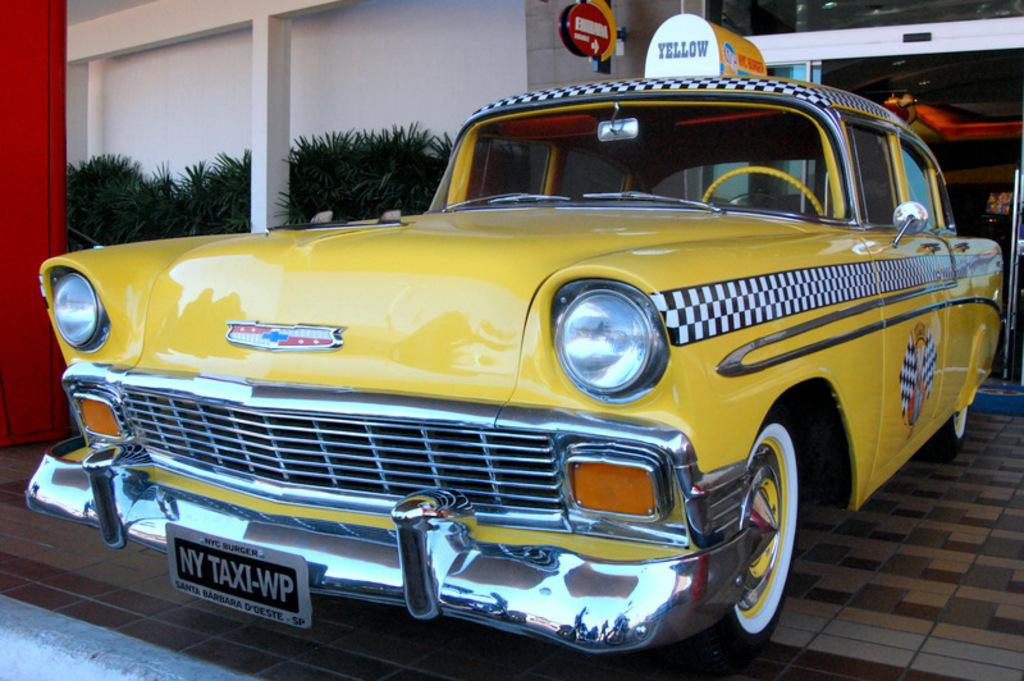<image>
Share a concise interpretation of the image provided. A classic taxi cab with checkerboard pinstripe has a large sign on top that says Yellow. 